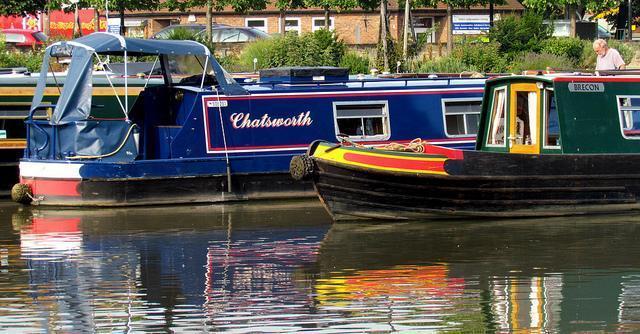How many boats are in the picture?
Give a very brief answer. 2. 